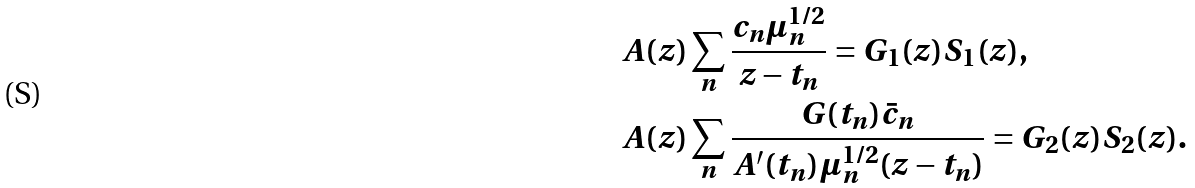Convert formula to latex. <formula><loc_0><loc_0><loc_500><loc_500>& A ( z ) \sum _ { n } \frac { c _ { n } \mu _ { n } ^ { 1 / 2 } } { z - t _ { n } } = G _ { 1 } ( z ) S _ { 1 } ( z ) , \\ & A ( z ) \sum _ { n } \frac { G ( t _ { n } ) \bar { c } _ { n } } { A ^ { \prime } ( t _ { n } ) \mu _ { n } ^ { 1 / 2 } ( z - t _ { n } ) } = G _ { 2 } ( z ) S _ { 2 } ( z ) .</formula> 